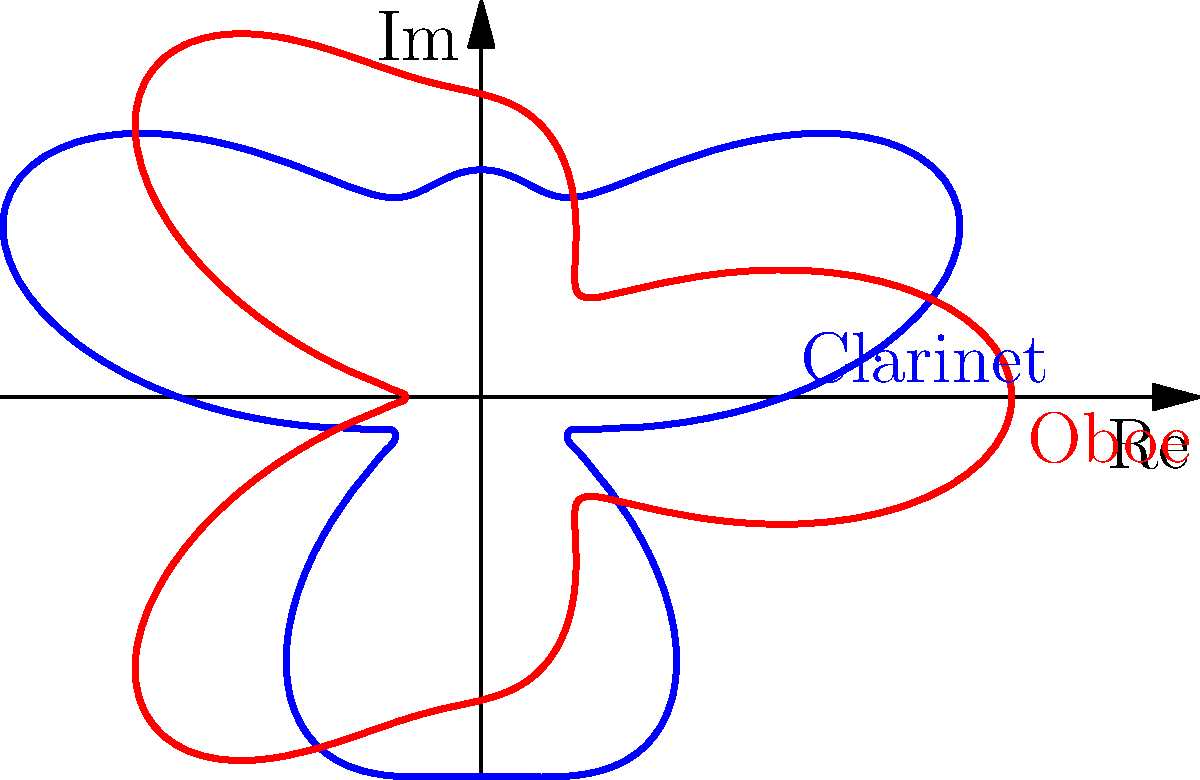The polar graph shows the interference pattern of a clarinet and oboe duet. The blue curve represents the clarinet's sound wave, given by the equation $r = 2 + \sin(3\theta) + 0.5\sin(5\theta)$, while the red curve represents the oboe's sound wave, given by $r = 2 + \cos(3\theta) + 0.5\cos(5\theta)$. At how many points do the two curves intersect, creating perfect harmony between the instruments? To find the number of intersection points, we need to follow these steps:

1) The curves intersect when their radii are equal for the same angle $\theta$. This occurs when:

   $2 + \sin(3\theta) + 0.5\sin(5\theta) = 2 + \cos(3\theta) + 0.5\cos(5\theta)$

2) Simplifying this equation:

   $\sin(3\theta) + 0.5\sin(5\theta) = \cos(3\theta) + 0.5\cos(5\theta)$

3) This equation is satisfied when:
   
   $\sin(3\theta) = \cos(3\theta)$ and $\sin(5\theta) = \cos(5\theta)$

4) The general solution for $\sin(x) = \cos(x)$ is $x = \frac{\pi}{4} + n\pi$, where $n$ is an integer.

5) For $3\theta$, this gives us:
   
   $3\theta = \frac{\pi}{4} + n\pi$
   $\theta = \frac{\pi}{12} + \frac{n\pi}{3}$

6) The solution repeats every $\frac{2\pi}{3}$, which means there are 3 solutions in the range $[0, 2\pi)$.

7) Each of these solutions also satisfies $\sin(5\theta) = \cos(5\theta)$ because $5(\frac{\pi}{12} + \frac{n\pi}{3}) = \frac{5\pi}{12} + \frac{5n\pi}{3}$, which is of the form $\frac{\pi}{4} + m\pi$.

Therefore, the curves intersect at 3 points in one complete revolution.
Answer: 3 points 